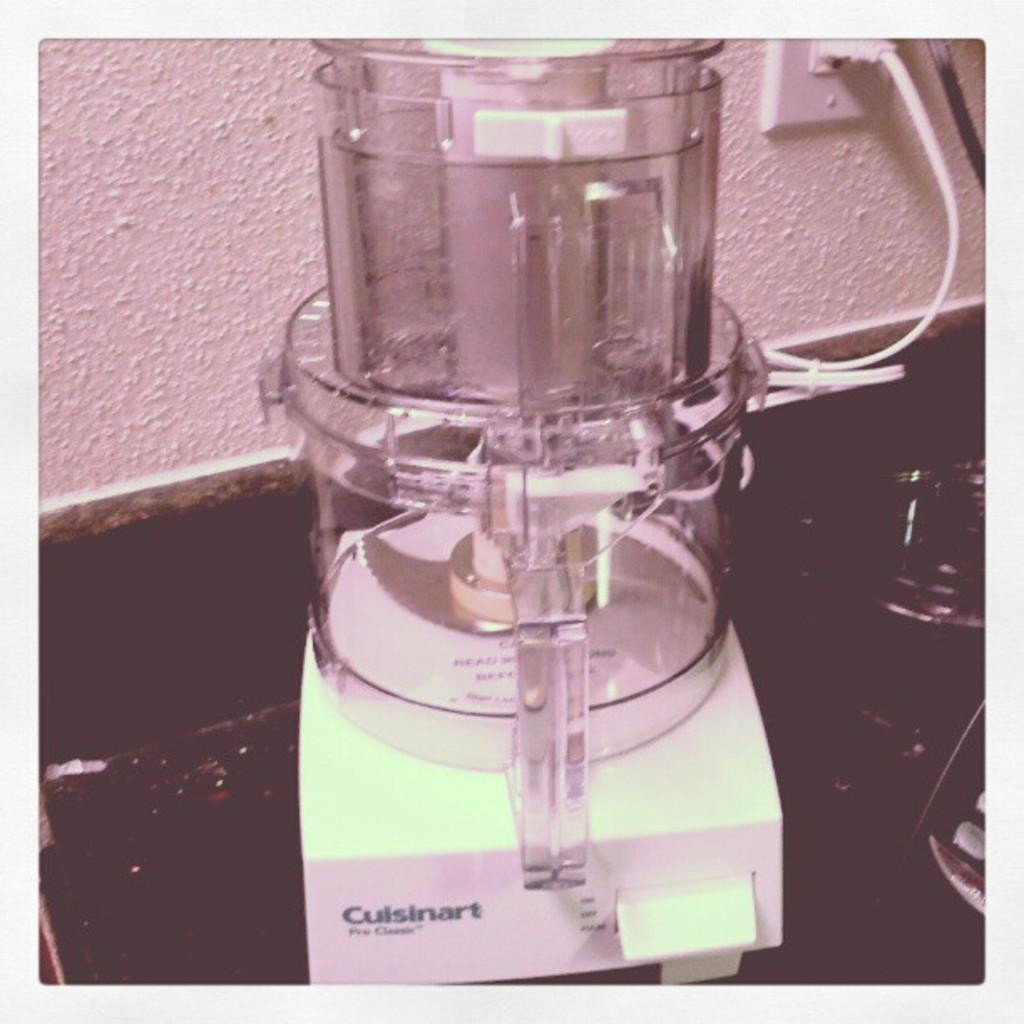<image>
Share a concise interpretation of the image provided. a picture of a Cuisinart Pro Classic Food Processor that is plugged in. 